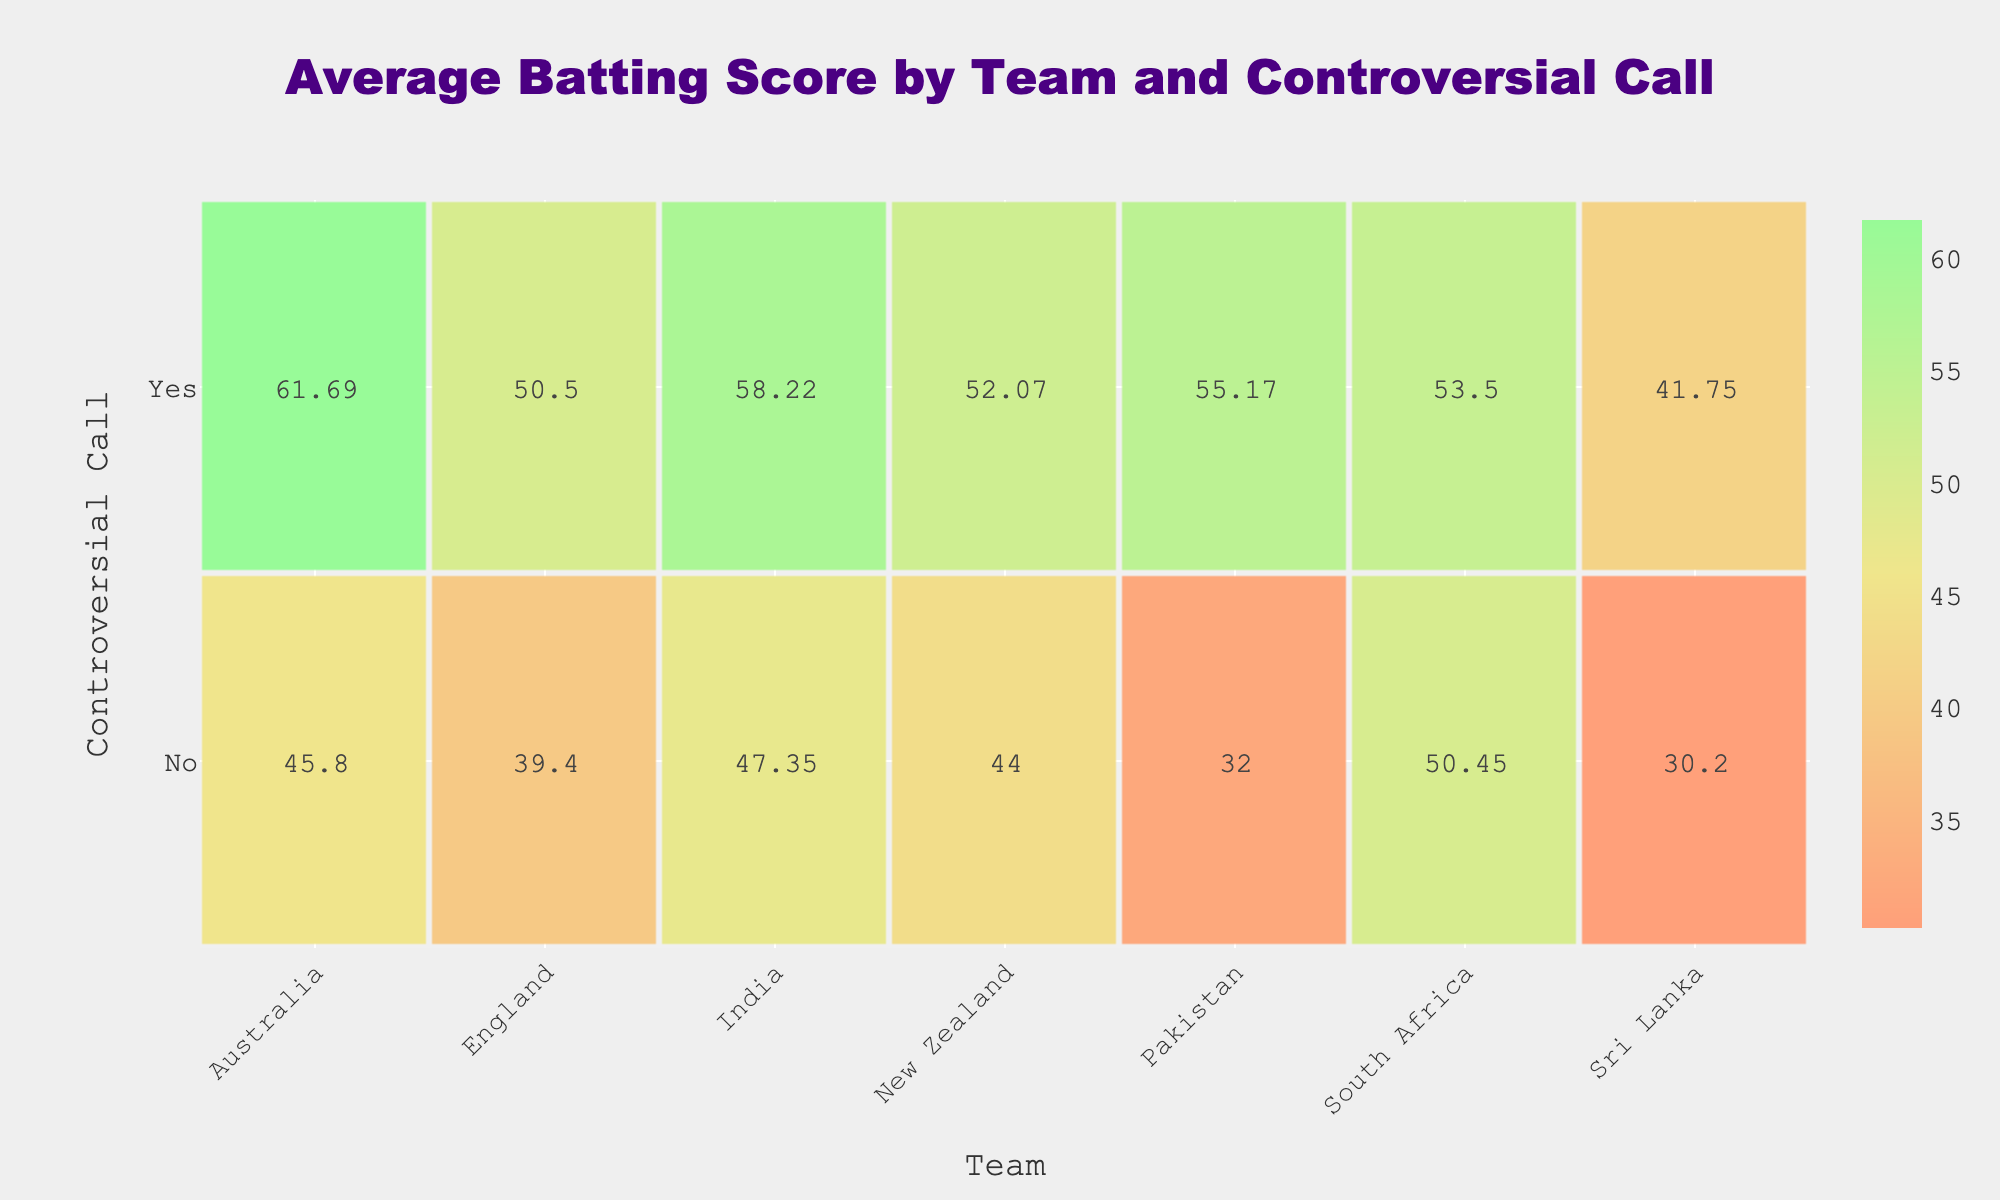What is the batting average of Rohit Sharma in matches with controversial calls? In the table, while looking for the record of Rohit Sharma, there is an entry under "Controversial_Call" marked "Yes" for Match 1, which shows his batting average as 58.22.
Answer: 58.22 Which team has the highest batting average in matches without controversial calls? By analyzing the "No" row in the contingency table, we can see the following averages: India (47.35), Australia (45.80), England (39.40), Pakistan (32.00), Sri Lanka (30.20), South Africa (50.45), and New Zealand (44.00). Comparing these, South Africa has the highest average of 50.45.
Answer: South Africa Is Babar Azam's average higher than Ben Stokes' average? Babar Azam's average, based on the "Yes" entry for Pakistan, is 55.17. On the other hand, Ben Stokes' average, recorded under "No" for England, is 39.40. Since 55.17 is greater than 39.40, Babar Azam's average is indeed higher.
Answer: Yes What is the difference between the batting averages of Australia in matches with and without controversial calls? To find the difference, we first note that the average for Australia in matches with controversial calls is 61.69, and without, it is 45.80. The difference is calculated as 61.69 - 45.80 = 15.89, indicating that Australia performs better in controversial matches.
Answer: 15.89 Which team had a higher average in matches with controversial calls: India or Pakistan? Analyzing the averages, India has 58.22 and Pakistan has 55.17 in matches where controversial calls were present. Since 58.22 is greater than 55.17, we conclude that India had a higher average in those matches.
Answer: India What is the average batting score for teams in matches with controversial calls? Consider the teams with averages for matches with controversial calls: India (58.22), Australia (61.69), England (50.50), Pakistan (55.17), Sri Lanka (41.75), South Africa (53.50), and New Zealand (52.07). To find the average: (58.22 + 61.69 + 50.50 + 55.17 + 41.75 + 53.50 + 52.07) / 7 = 52.12. Thus, the average score is approximately 52.12.
Answer: 52.12 Did K.L. Rahul have a better average than Dinesh Chandimal? K.L. Rahul's batting average is 47.35 (in matches without controversial calls) while Dinesh Chandimal's is 30.20 (also without controversial calls). Since 47.35 is greater than 30.20, K.L. Rahul did have a better average.
Answer: Yes What is the average batting score for teams in matches without controversial calls? Looking at the averages for teams in matches with no controversial calls: India (47.35), Australia (45.80), England (39.40), Pakistan (32.00), Sri Lanka (30.20), South Africa (50.45), and New Zealand (44.00). The average is calculated as (47.35 + 45.80 + 39.40 + 32.00 + 30.20 + 50.45 + 44.00) / 7 = 39.86. This score approximates to 39.86.
Answer: 39.86 